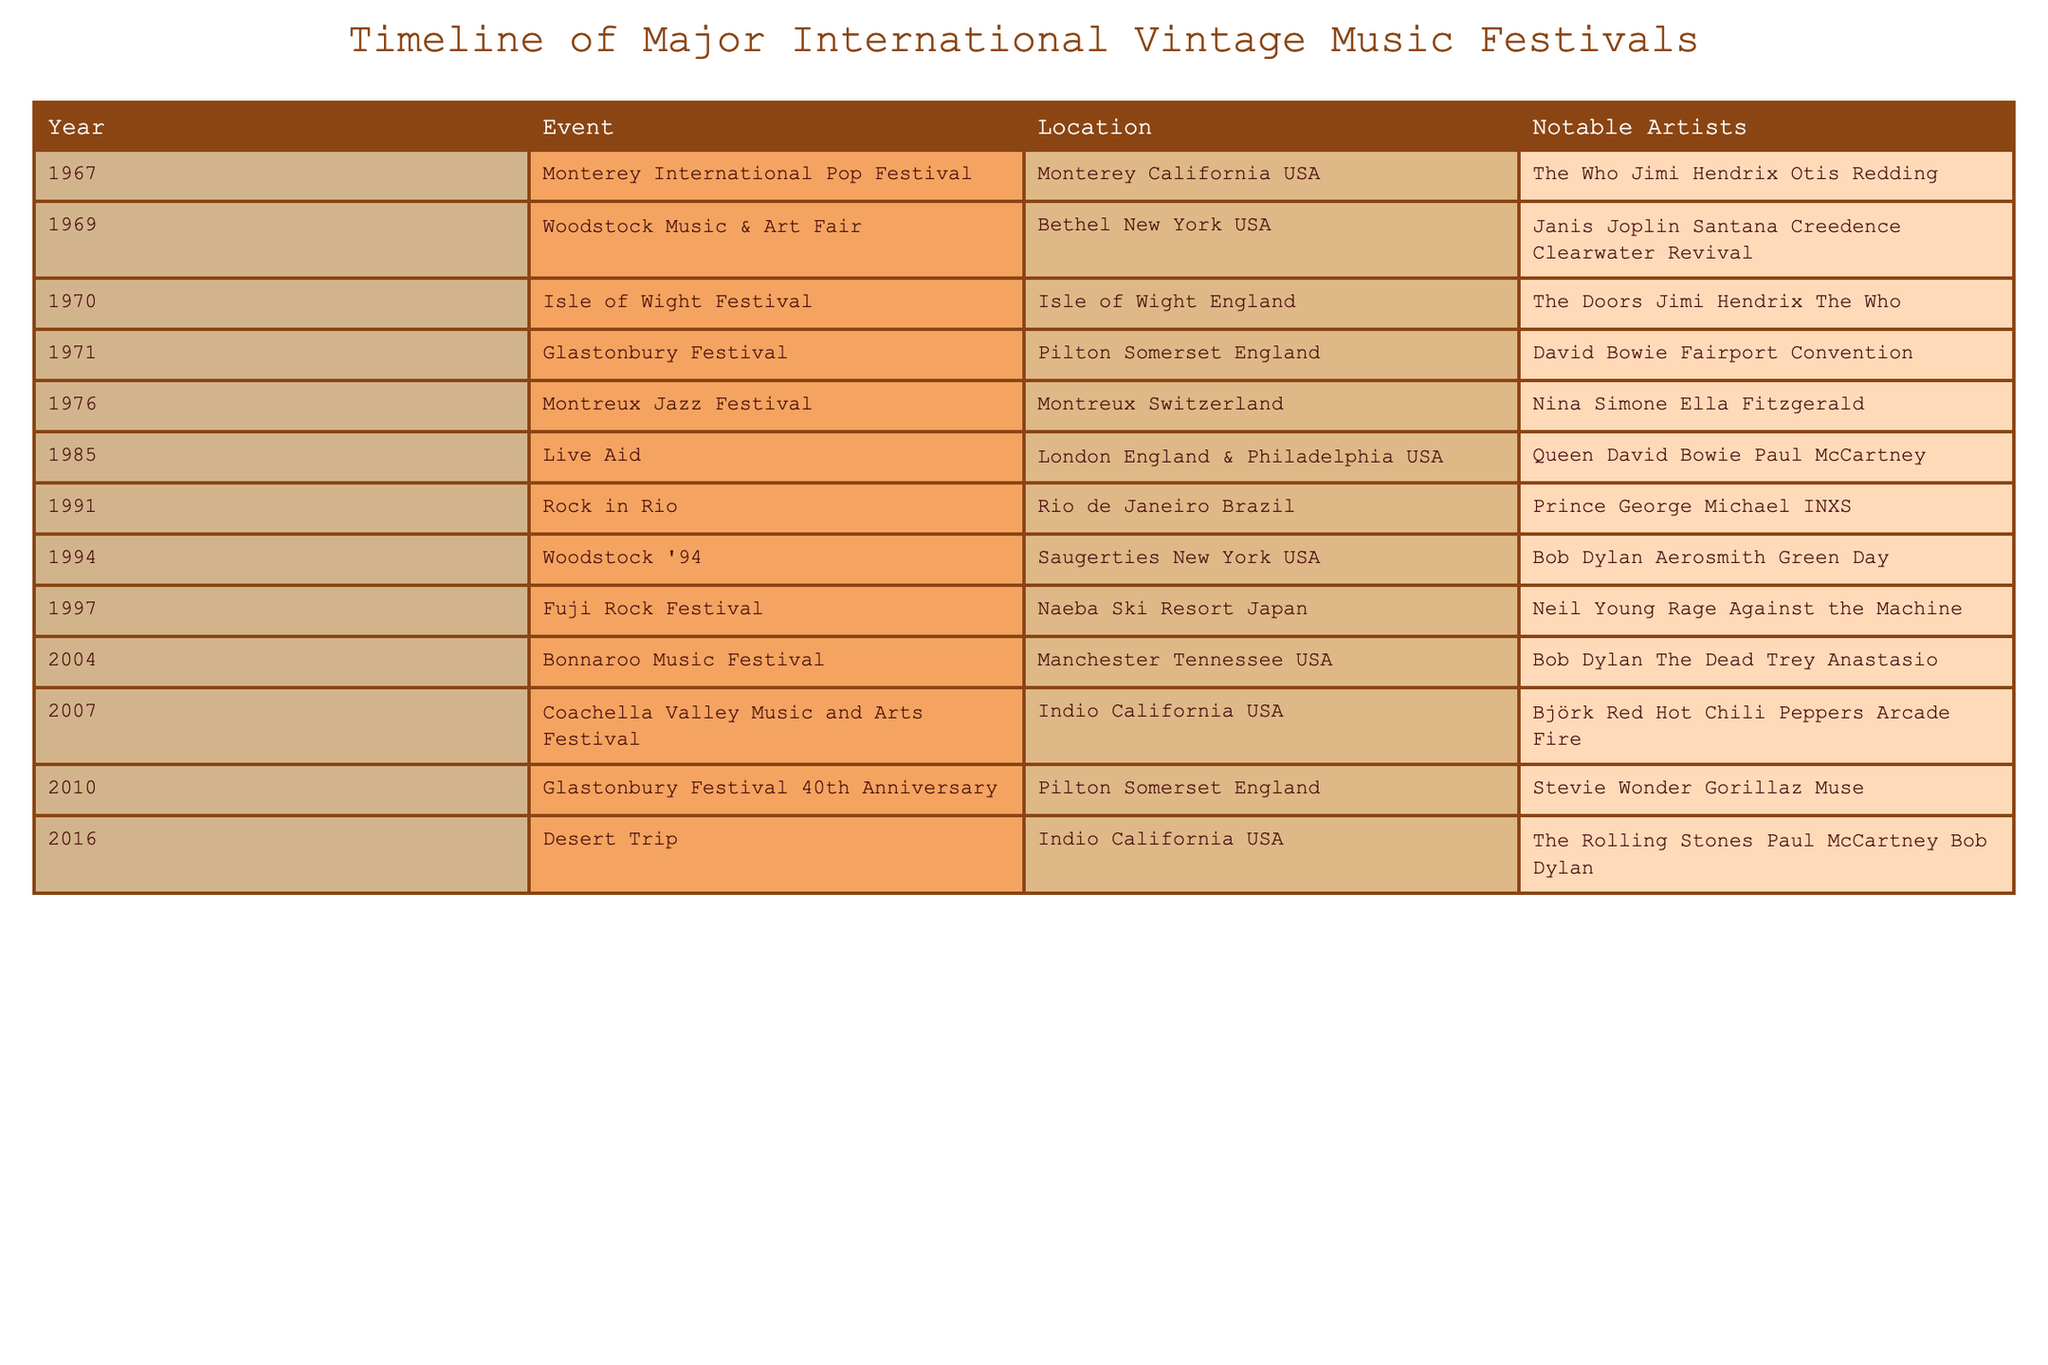What year did the Woodstock Music & Art Fair take place? The table lists the events in chronological order. By looking for the specific event "Woodstock Music & Art Fair", we find it is associated with the year 1969.
Answer: 1969 Which festival had The Rolling Stones as a notable artist? The table includes the festival names and notable artists. By scanning through the "Notable Artists" column, we see "The Rolling Stones" listed under the "Desert Trip" event in 2016.
Answer: Desert Trip How many music festivals took place in the 1970s? To find the number of festivals in the 1970s, I will count the entries from 1970 to 1979 in the table. The festivals are: Isle of Wight Festival (1970), Glastonbury Festival (1971), and Montreux Jazz Festival (1976). This gives us a total of 3 festivals.
Answer: 3 Was the Live Aid event held in the USA? By looking at the "Location" column for Live Aid, I see it mentions both London, England and Philadelphia, USA, confirming it was held in the USA.
Answer: Yes In how many festivals did the notable artist Bob Dylan perform? I will review the "Notable Artists" column for occurrences of Bob Dylan. He is listed as a notable artist in three events: Woodstock '94 (1994), Bonnaroo Music Festival (2004), and Desert Trip (2016). Therefore, he performed in 3 festivals.
Answer: 3 Which festival had the most notable artists listed? By examining the "Notable Artists" for each event, I notice that both the 1985 Live Aid and 2016 Desert Trip events have three notable artists listed. Since both have the highest count, I would refer to them.
Answer: Live Aid and Desert Trip What is the total number of different festival locations mentioned in the table? I will note the unique locations listed. They are: Monterey (USA), Bethel (USA), Isle of Wight (England), Pilton (England), Montreux (Switzerland), London (England), Philadelphia (USA), Rio de Janeiro (Brazil), Saugerties (USA), Naeba Ski Resort (Japan), Manchester (USA), Indio (USA). Counting these gives a total of 12 unique locations.
Answer: 12 Did Nina Simone perform at a festival outside of Europe? I look at the "Notable Artists" for Nina Simone, and see she is listed under the Montreux Jazz Festival, which is located in Switzerland (Europe). Therefore, she did not perform outside of Europe.
Answer: No 